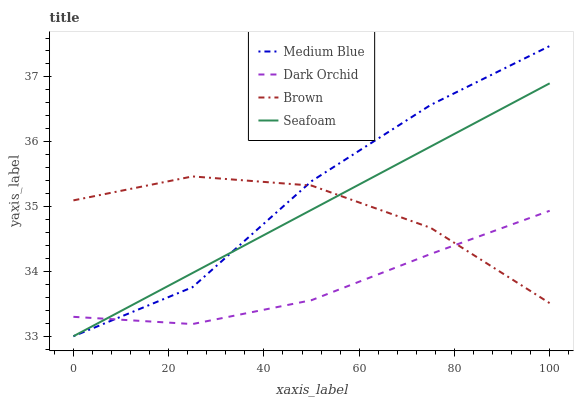Does Dark Orchid have the minimum area under the curve?
Answer yes or no. Yes. Does Medium Blue have the maximum area under the curve?
Answer yes or no. Yes. Does Seafoam have the minimum area under the curve?
Answer yes or no. No. Does Seafoam have the maximum area under the curve?
Answer yes or no. No. Is Seafoam the smoothest?
Answer yes or no. Yes. Is Medium Blue the roughest?
Answer yes or no. Yes. Is Medium Blue the smoothest?
Answer yes or no. No. Is Seafoam the roughest?
Answer yes or no. No. Does Dark Orchid have the lowest value?
Answer yes or no. No. Does Medium Blue have the highest value?
Answer yes or no. Yes. Does Seafoam have the highest value?
Answer yes or no. No. Does Seafoam intersect Dark Orchid?
Answer yes or no. Yes. Is Seafoam less than Dark Orchid?
Answer yes or no. No. Is Seafoam greater than Dark Orchid?
Answer yes or no. No. 